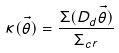Convert formula to latex. <formula><loc_0><loc_0><loc_500><loc_500>\kappa ( \vec { \theta } ) = \frac { \Sigma ( D _ { d } \vec { \theta } ) } { \Sigma _ { c r } }</formula> 